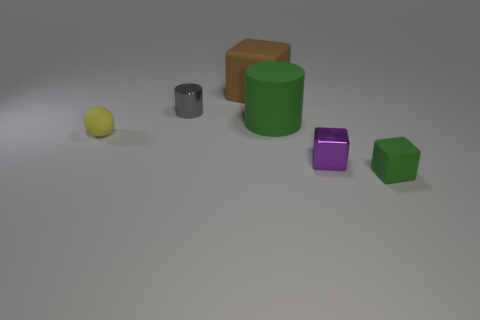Is the number of yellow objects to the right of the purple shiny thing less than the number of brown cubes?
Your response must be concise. Yes. Is the tiny ball the same color as the big block?
Keep it short and to the point. No. Are there any other things that have the same shape as the small yellow rubber thing?
Offer a terse response. No. Are there fewer cylinders than large cyan metallic blocks?
Offer a terse response. No. What is the color of the cylinder that is right of the tiny metal object left of the large green rubber object?
Your response must be concise. Green. There is a block on the right side of the tiny block to the left of the green matte object that is in front of the yellow thing; what is its material?
Keep it short and to the point. Rubber. Is the size of the rubber block behind the gray cylinder the same as the large green rubber cylinder?
Make the answer very short. Yes. There is a cylinder that is in front of the gray metallic cylinder; what material is it?
Provide a short and direct response. Rubber. Is the number of yellow rubber objects greater than the number of gray balls?
Your answer should be compact. Yes. What number of objects are blocks that are behind the tiny gray metal cylinder or gray cylinders?
Your response must be concise. 2. 